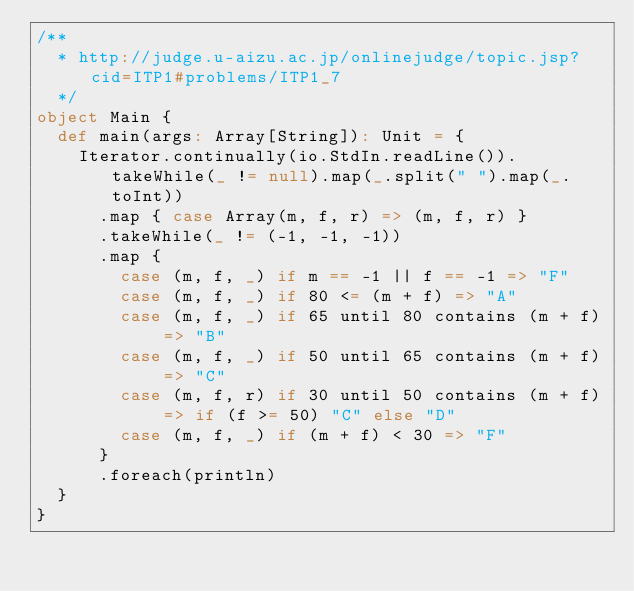<code> <loc_0><loc_0><loc_500><loc_500><_Scala_>/**
  * http://judge.u-aizu.ac.jp/onlinejudge/topic.jsp?cid=ITP1#problems/ITP1_7
  */
object Main {
  def main(args: Array[String]): Unit = {
    Iterator.continually(io.StdIn.readLine()).takeWhile(_ != null).map(_.split(" ").map(_.toInt))
      .map { case Array(m, f, r) => (m, f, r) }
      .takeWhile(_ != (-1, -1, -1))
      .map {
        case (m, f, _) if m == -1 || f == -1 => "F"
        case (m, f, _) if 80 <= (m + f) => "A"
        case (m, f, _) if 65 until 80 contains (m + f) => "B"
        case (m, f, _) if 50 until 65 contains (m + f) => "C"
        case (m, f, r) if 30 until 50 contains (m + f) => if (f >= 50) "C" else "D"
        case (m, f, _) if (m + f) < 30 => "F"
      }
      .foreach(println)
  }
}</code> 